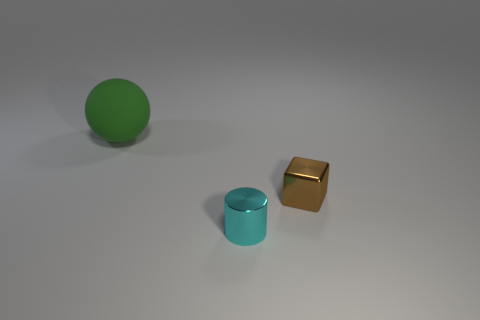Is there anything else that is the same material as the large object?
Offer a very short reply. No. What color is the other object that is the same material as the brown object?
Offer a terse response. Cyan. What material is the small thing that is right of the tiny object that is to the left of the block?
Your answer should be very brief. Metal. What number of things are things left of the small shiny cube or objects in front of the big rubber ball?
Provide a succinct answer. 3. There is a thing on the left side of the tiny metallic thing that is in front of the small object that is to the right of the cyan metallic thing; what is its size?
Keep it short and to the point. Large. Are there the same number of big green spheres that are on the right side of the tiny cyan shiny thing and large cyan metal things?
Offer a very short reply. Yes. Are there any other things that are the same shape as the big green object?
Make the answer very short. No. How many other objects are the same material as the tiny brown cube?
Your response must be concise. 1. What material is the cube?
Provide a short and direct response. Metal. Are there more brown blocks that are in front of the large green rubber thing than blue matte cubes?
Your answer should be very brief. Yes. 